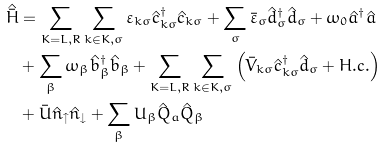Convert formula to latex. <formula><loc_0><loc_0><loc_500><loc_500>\hat { \bar { H } } & = \sum _ { K = L , R } \sum _ { k \in K , \sigma } \varepsilon _ { k \sigma } \hat { c } ^ { \dagger } _ { k \sigma } \hat { c } _ { k \sigma } + \sum _ { \sigma } \bar { \varepsilon } _ { \sigma } \hat { d } ^ { \dagger } _ { \sigma } \hat { d } _ { \sigma } + \omega _ { 0 } \hat { a } ^ { \dagger } \hat { a } \\ & + \sum _ { \beta } \omega _ { \beta } \hat { b } ^ { \dagger } _ { \beta } \hat { b } _ { \beta } + \sum _ { K = L , R } \sum _ { k \in K , \sigma } \left ( \bar { V } _ { k \sigma } \hat { c } ^ { \dagger } _ { k \sigma } \hat { d } _ { \sigma } + H . c . \right ) \\ & + \bar { U } \hat { n } _ { \uparrow } \hat { n } _ { \downarrow } + \sum _ { \beta } U _ { \beta } \hat { Q } _ { a } \hat { Q } _ { \beta }</formula> 